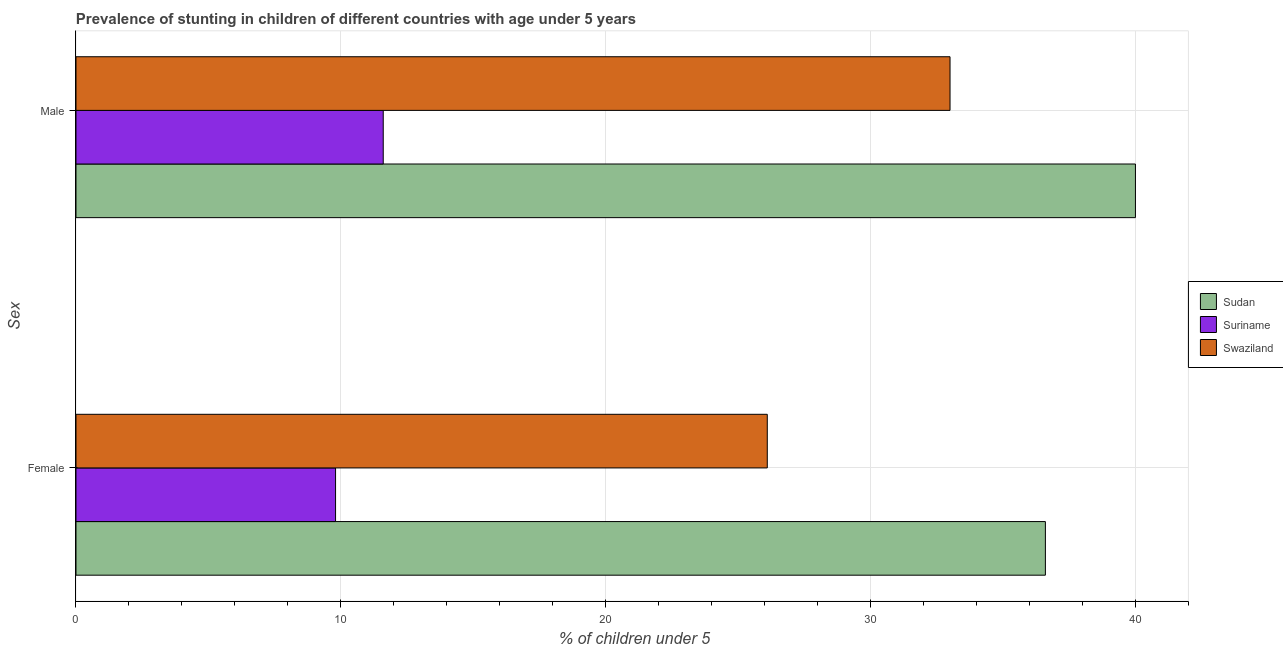Are the number of bars per tick equal to the number of legend labels?
Provide a succinct answer. Yes. Are the number of bars on each tick of the Y-axis equal?
Keep it short and to the point. Yes. How many bars are there on the 2nd tick from the top?
Your response must be concise. 3. How many bars are there on the 1st tick from the bottom?
Give a very brief answer. 3. What is the label of the 1st group of bars from the top?
Offer a very short reply. Male. What is the percentage of stunted female children in Sudan?
Ensure brevity in your answer.  36.6. Across all countries, what is the maximum percentage of stunted female children?
Offer a very short reply. 36.6. Across all countries, what is the minimum percentage of stunted female children?
Give a very brief answer. 9.8. In which country was the percentage of stunted male children maximum?
Keep it short and to the point. Sudan. In which country was the percentage of stunted male children minimum?
Your answer should be compact. Suriname. What is the total percentage of stunted female children in the graph?
Make the answer very short. 72.5. What is the difference between the percentage of stunted male children in Sudan and that in Suriname?
Offer a terse response. 28.4. What is the difference between the percentage of stunted female children in Sudan and the percentage of stunted male children in Swaziland?
Keep it short and to the point. 3.6. What is the average percentage of stunted female children per country?
Provide a succinct answer. 24.17. What is the difference between the percentage of stunted male children and percentage of stunted female children in Sudan?
Provide a short and direct response. 3.4. What is the ratio of the percentage of stunted female children in Sudan to that in Suriname?
Your response must be concise. 3.73. What does the 3rd bar from the top in Female represents?
Ensure brevity in your answer.  Sudan. What does the 3rd bar from the bottom in Male represents?
Make the answer very short. Swaziland. How many bars are there?
Your answer should be compact. 6. Are all the bars in the graph horizontal?
Your response must be concise. Yes. Does the graph contain grids?
Your answer should be compact. Yes. Where does the legend appear in the graph?
Keep it short and to the point. Center right. What is the title of the graph?
Provide a succinct answer. Prevalence of stunting in children of different countries with age under 5 years. What is the label or title of the X-axis?
Offer a terse response.  % of children under 5. What is the label or title of the Y-axis?
Give a very brief answer. Sex. What is the  % of children under 5 of Sudan in Female?
Your response must be concise. 36.6. What is the  % of children under 5 in Suriname in Female?
Your response must be concise. 9.8. What is the  % of children under 5 of Swaziland in Female?
Provide a succinct answer. 26.1. What is the  % of children under 5 in Sudan in Male?
Your response must be concise. 40. What is the  % of children under 5 of Suriname in Male?
Your response must be concise. 11.6. What is the  % of children under 5 in Swaziland in Male?
Provide a short and direct response. 33. Across all Sex, what is the maximum  % of children under 5 of Suriname?
Provide a short and direct response. 11.6. Across all Sex, what is the maximum  % of children under 5 of Swaziland?
Make the answer very short. 33. Across all Sex, what is the minimum  % of children under 5 in Sudan?
Give a very brief answer. 36.6. Across all Sex, what is the minimum  % of children under 5 of Suriname?
Your answer should be compact. 9.8. Across all Sex, what is the minimum  % of children under 5 of Swaziland?
Your response must be concise. 26.1. What is the total  % of children under 5 in Sudan in the graph?
Provide a short and direct response. 76.6. What is the total  % of children under 5 of Suriname in the graph?
Make the answer very short. 21.4. What is the total  % of children under 5 in Swaziland in the graph?
Provide a succinct answer. 59.1. What is the difference between the  % of children under 5 in Suriname in Female and that in Male?
Provide a succinct answer. -1.8. What is the difference between the  % of children under 5 in Sudan in Female and the  % of children under 5 in Swaziland in Male?
Give a very brief answer. 3.6. What is the difference between the  % of children under 5 of Suriname in Female and the  % of children under 5 of Swaziland in Male?
Offer a very short reply. -23.2. What is the average  % of children under 5 of Sudan per Sex?
Give a very brief answer. 38.3. What is the average  % of children under 5 of Suriname per Sex?
Give a very brief answer. 10.7. What is the average  % of children under 5 of Swaziland per Sex?
Give a very brief answer. 29.55. What is the difference between the  % of children under 5 in Sudan and  % of children under 5 in Suriname in Female?
Offer a terse response. 26.8. What is the difference between the  % of children under 5 in Suriname and  % of children under 5 in Swaziland in Female?
Keep it short and to the point. -16.3. What is the difference between the  % of children under 5 in Sudan and  % of children under 5 in Suriname in Male?
Give a very brief answer. 28.4. What is the difference between the  % of children under 5 in Suriname and  % of children under 5 in Swaziland in Male?
Your answer should be compact. -21.4. What is the ratio of the  % of children under 5 of Sudan in Female to that in Male?
Provide a short and direct response. 0.92. What is the ratio of the  % of children under 5 of Suriname in Female to that in Male?
Provide a succinct answer. 0.84. What is the ratio of the  % of children under 5 in Swaziland in Female to that in Male?
Ensure brevity in your answer.  0.79. What is the difference between the highest and the second highest  % of children under 5 in Swaziland?
Provide a short and direct response. 6.9. What is the difference between the highest and the lowest  % of children under 5 in Swaziland?
Your response must be concise. 6.9. 